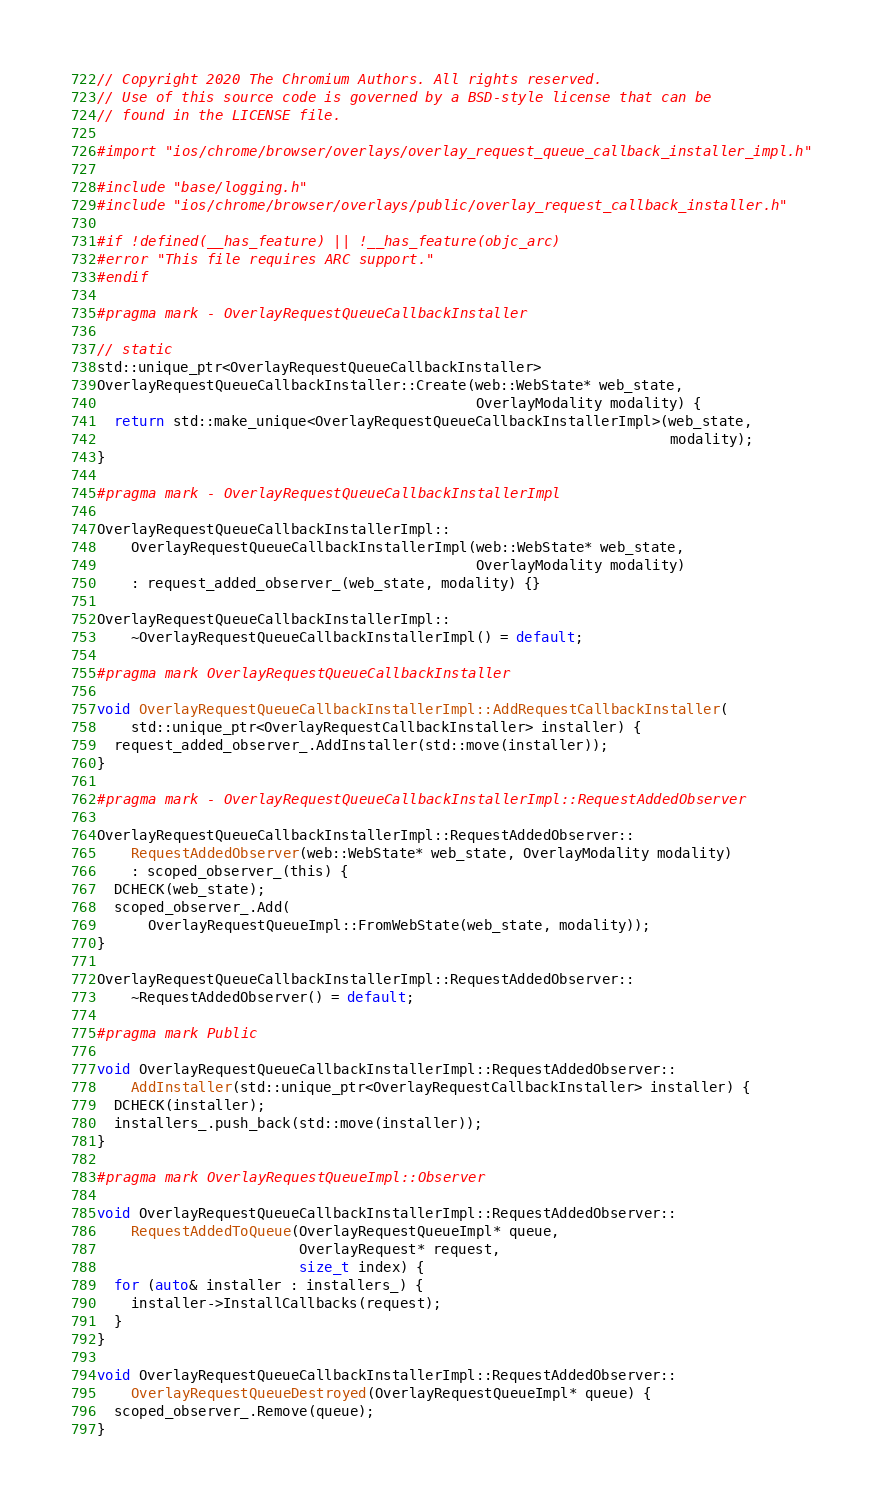<code> <loc_0><loc_0><loc_500><loc_500><_ObjectiveC_>// Copyright 2020 The Chromium Authors. All rights reserved.
// Use of this source code is governed by a BSD-style license that can be
// found in the LICENSE file.

#import "ios/chrome/browser/overlays/overlay_request_queue_callback_installer_impl.h"

#include "base/logging.h"
#include "ios/chrome/browser/overlays/public/overlay_request_callback_installer.h"

#if !defined(__has_feature) || !__has_feature(objc_arc)
#error "This file requires ARC support."
#endif

#pragma mark - OverlayRequestQueueCallbackInstaller

// static
std::unique_ptr<OverlayRequestQueueCallbackInstaller>
OverlayRequestQueueCallbackInstaller::Create(web::WebState* web_state,
                                             OverlayModality modality) {
  return std::make_unique<OverlayRequestQueueCallbackInstallerImpl>(web_state,
                                                                    modality);
}

#pragma mark - OverlayRequestQueueCallbackInstallerImpl

OverlayRequestQueueCallbackInstallerImpl::
    OverlayRequestQueueCallbackInstallerImpl(web::WebState* web_state,
                                             OverlayModality modality)
    : request_added_observer_(web_state, modality) {}

OverlayRequestQueueCallbackInstallerImpl::
    ~OverlayRequestQueueCallbackInstallerImpl() = default;

#pragma mark OverlayRequestQueueCallbackInstaller

void OverlayRequestQueueCallbackInstallerImpl::AddRequestCallbackInstaller(
    std::unique_ptr<OverlayRequestCallbackInstaller> installer) {
  request_added_observer_.AddInstaller(std::move(installer));
}

#pragma mark - OverlayRequestQueueCallbackInstallerImpl::RequestAddedObserver

OverlayRequestQueueCallbackInstallerImpl::RequestAddedObserver::
    RequestAddedObserver(web::WebState* web_state, OverlayModality modality)
    : scoped_observer_(this) {
  DCHECK(web_state);
  scoped_observer_.Add(
      OverlayRequestQueueImpl::FromWebState(web_state, modality));
}

OverlayRequestQueueCallbackInstallerImpl::RequestAddedObserver::
    ~RequestAddedObserver() = default;

#pragma mark Public

void OverlayRequestQueueCallbackInstallerImpl::RequestAddedObserver::
    AddInstaller(std::unique_ptr<OverlayRequestCallbackInstaller> installer) {
  DCHECK(installer);
  installers_.push_back(std::move(installer));
}

#pragma mark OverlayRequestQueueImpl::Observer

void OverlayRequestQueueCallbackInstallerImpl::RequestAddedObserver::
    RequestAddedToQueue(OverlayRequestQueueImpl* queue,
                        OverlayRequest* request,
                        size_t index) {
  for (auto& installer : installers_) {
    installer->InstallCallbacks(request);
  }
}

void OverlayRequestQueueCallbackInstallerImpl::RequestAddedObserver::
    OverlayRequestQueueDestroyed(OverlayRequestQueueImpl* queue) {
  scoped_observer_.Remove(queue);
}
</code> 